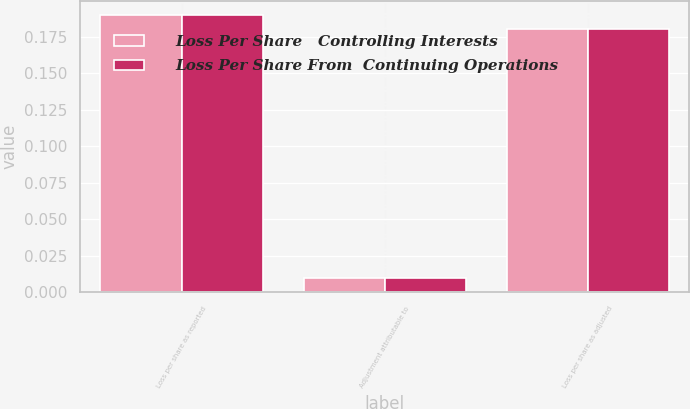Convert chart to OTSL. <chart><loc_0><loc_0><loc_500><loc_500><stacked_bar_chart><ecel><fcel>Loss per share as reported<fcel>Adjustment attributable to<fcel>Loss per share as adjusted<nl><fcel>Loss Per Share   Controlling Interests<fcel>0.19<fcel>0.01<fcel>0.18<nl><fcel>Loss Per Share From  Continuing Operations<fcel>0.19<fcel>0.01<fcel>0.18<nl></chart> 